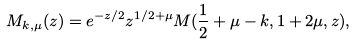<formula> <loc_0><loc_0><loc_500><loc_500>M _ { k , \mu } ( z ) = e ^ { - z / 2 } z ^ { 1 / 2 + \mu } M ( \frac { 1 } { 2 } + \mu - k , 1 + 2 \mu , z ) ,</formula> 